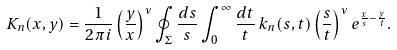Convert formula to latex. <formula><loc_0><loc_0><loc_500><loc_500>K _ { n } ( x , y ) = \frac { 1 } { 2 \pi i } \left ( \frac { y } { x } \right ) ^ { \nu } \oint _ { \Sigma } \frac { d s } { s } \int _ { 0 } ^ { \infty } \frac { d t } { t } \, k _ { n } ( s , t ) \left ( \frac { s } { t } \right ) ^ { \nu } e ^ { \frac { x } { s } - \frac { y } { t } } .</formula> 